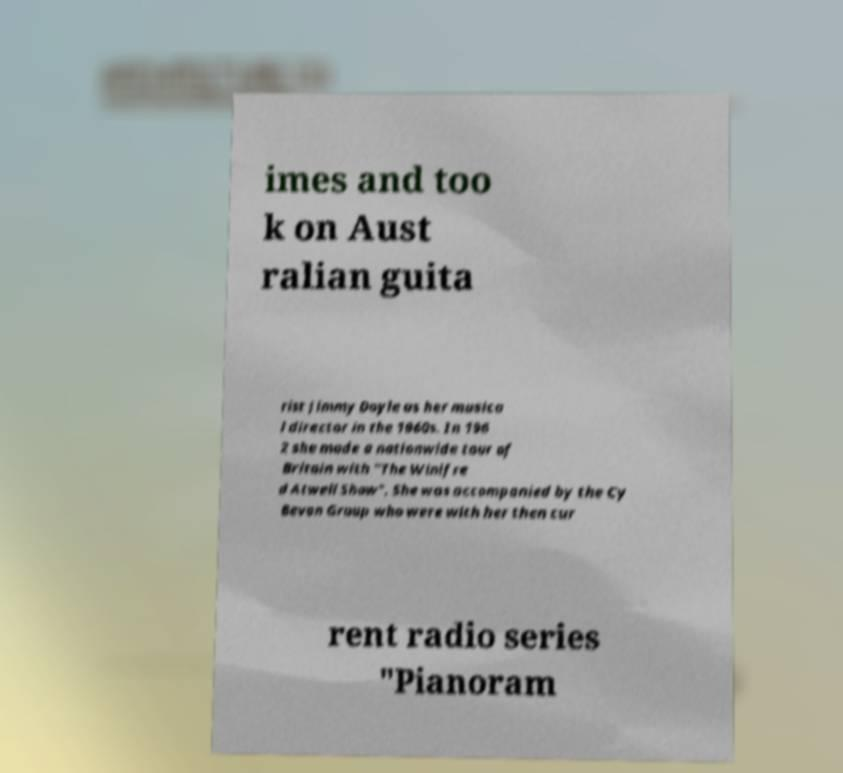Can you read and provide the text displayed in the image?This photo seems to have some interesting text. Can you extract and type it out for me? imes and too k on Aust ralian guita rist Jimmy Doyle as her musica l director in the 1960s. In 196 2 she made a nationwide tour of Britain with "The Winifre d Atwell Show". She was accompanied by the Cy Bevan Group who were with her then cur rent radio series "Pianoram 